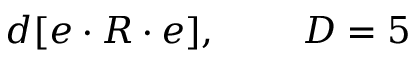Convert formula to latex. <formula><loc_0><loc_0><loc_500><loc_500>d [ e \cdot R \cdot e ] , \, D = 5</formula> 